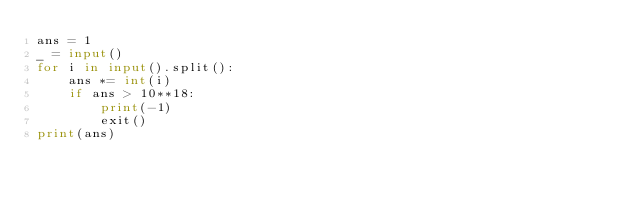<code> <loc_0><loc_0><loc_500><loc_500><_Python_>ans = 1
_ = input()
for i in input().split():
    ans *= int(i)
    if ans > 10**18:
        print(-1)
        exit()
print(ans)</code> 